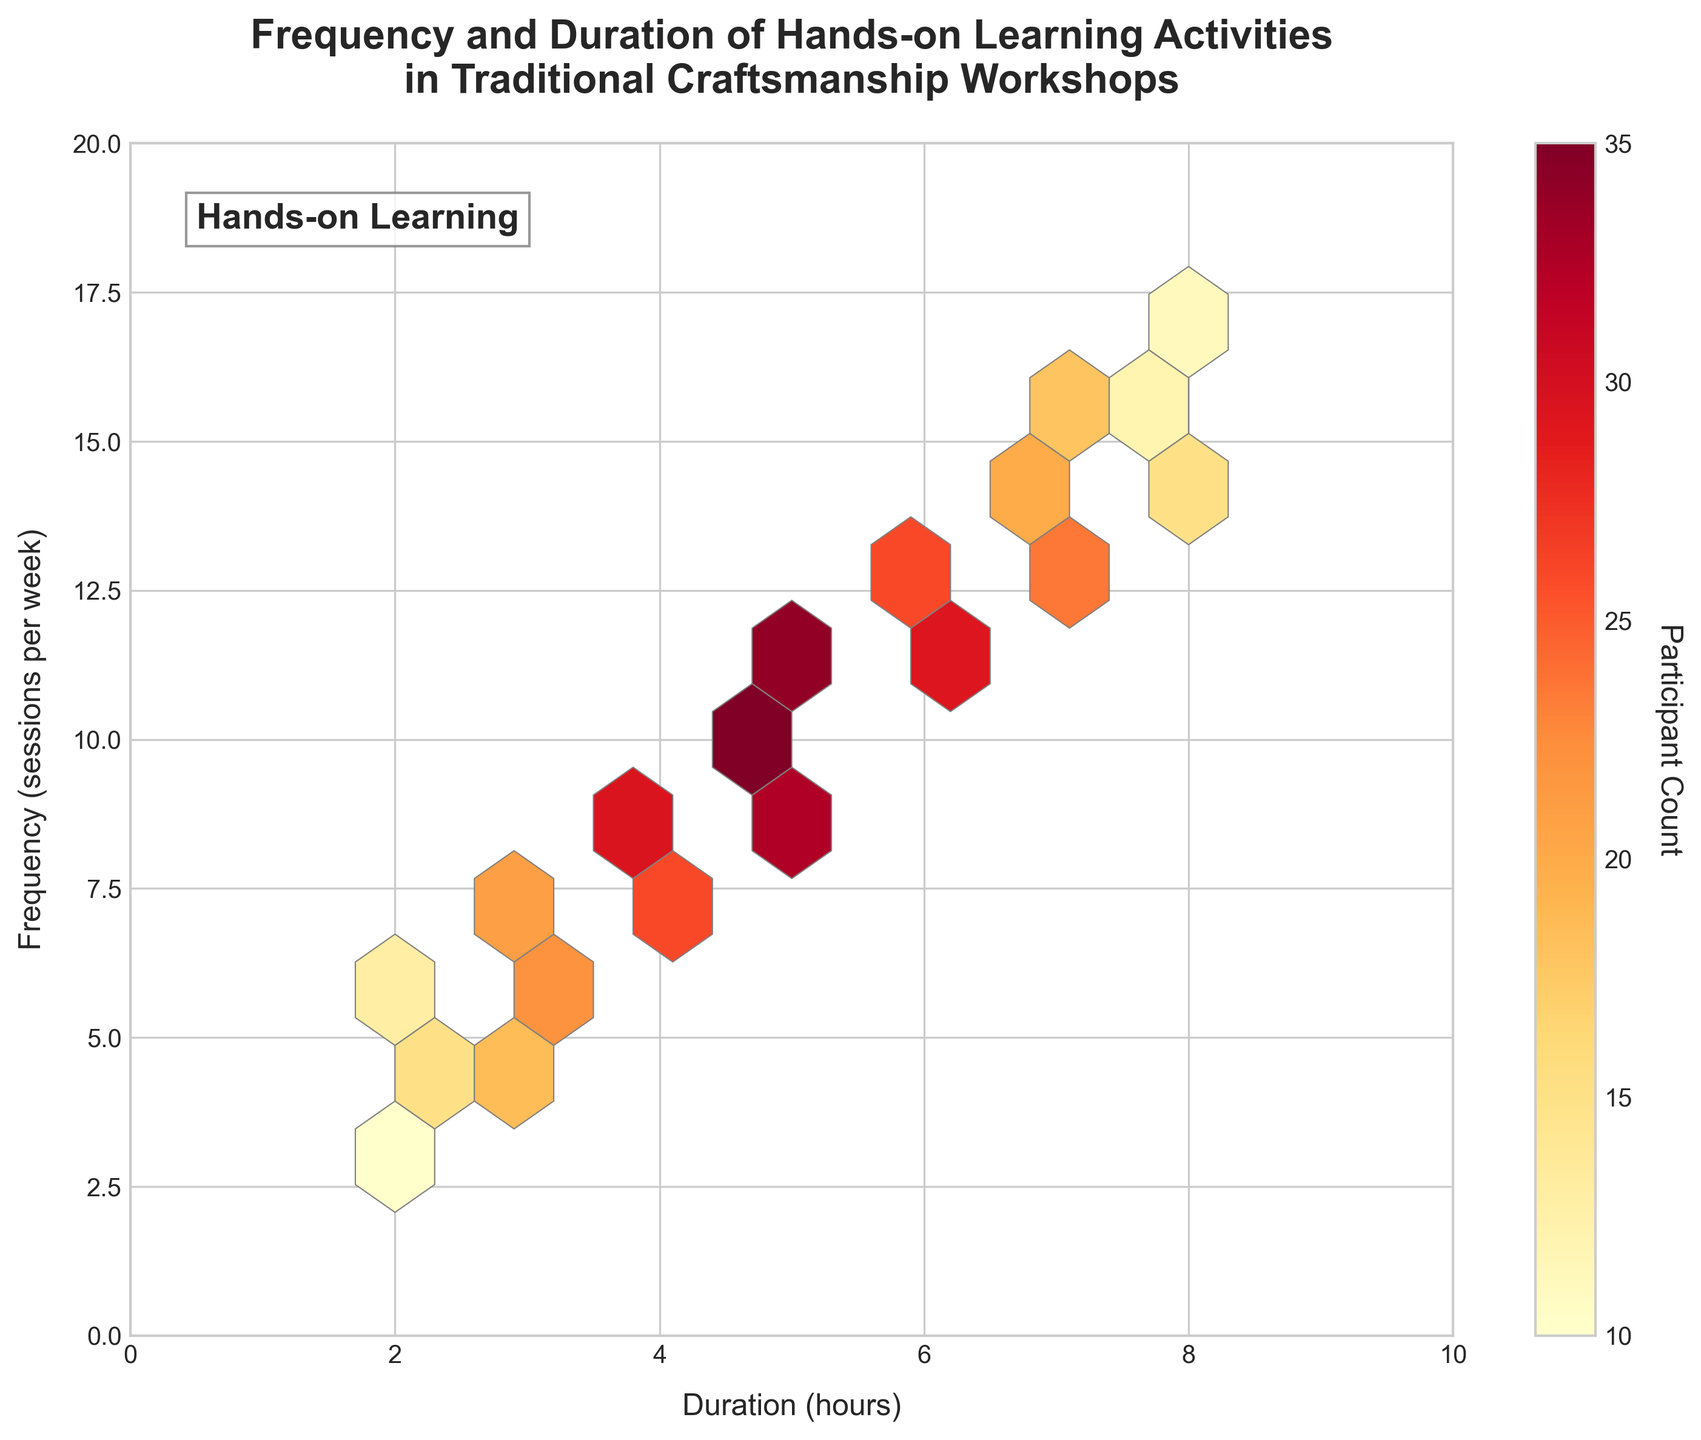What is the title of the hexbin plot? Look at the top of the plot, the exact wording of the main title will provide this information.
Answer: Frequency and Duration of Hands-on Learning Activities in Traditional Craftsmanship Workshops What do the x and y axes represent? Inspect the labels on both the x-axis and y-axis to see what each one is indicating.
Answer: Duration (hours) and Frequency (sessions per week) What is the meaning of the shaded color intensity in the hexbin plot? Check the color legend or color bar on the side of the plot to understand what the intensities represent.
Answer: Participant Count What is the range of values on the x-axis? Look at the minimum and maximum tick marks on the x-axis to determine the range.
Answer: 0 to 10 How many bins have the highest participant count, and what is that count? Look for the darkest (most intense) hexagons and find the corresponding color bar value.
Answer: One bin with a count of 35 What are the general trends observable in the plot between duration and frequency? Identify if there is any general pattern such as an increase or decrease in frequency.
Answer: As duration increases, frequency generally increases Are there more bins with high counts or low counts across the plot? Compare the number of hexagons that are darker (high count) versus lighter (low count).
Answer: More bins with lower counts In which range of duration do we find the maximum frequency of hands-on learning sessions? Look at the x-axis value corresponding to the bins with the highest frequency values.
Answer: 5 to 6 hours How do frequency values between 6 and 12 sessions per week generally correlate with participant counts? Focus on the y-axis values from 6 to 12 and examine the color intensity of hexagons for these y-values to understand the relation with participant counts.
Answer: Higher participant counts What is the median duration for high-frequency sessions (e.g., 10+ per week)? Identify the x-values (duration) most frequently associated with y-values (sessions per week) of 10 or more and find the median value.
Answer: 5 hours 